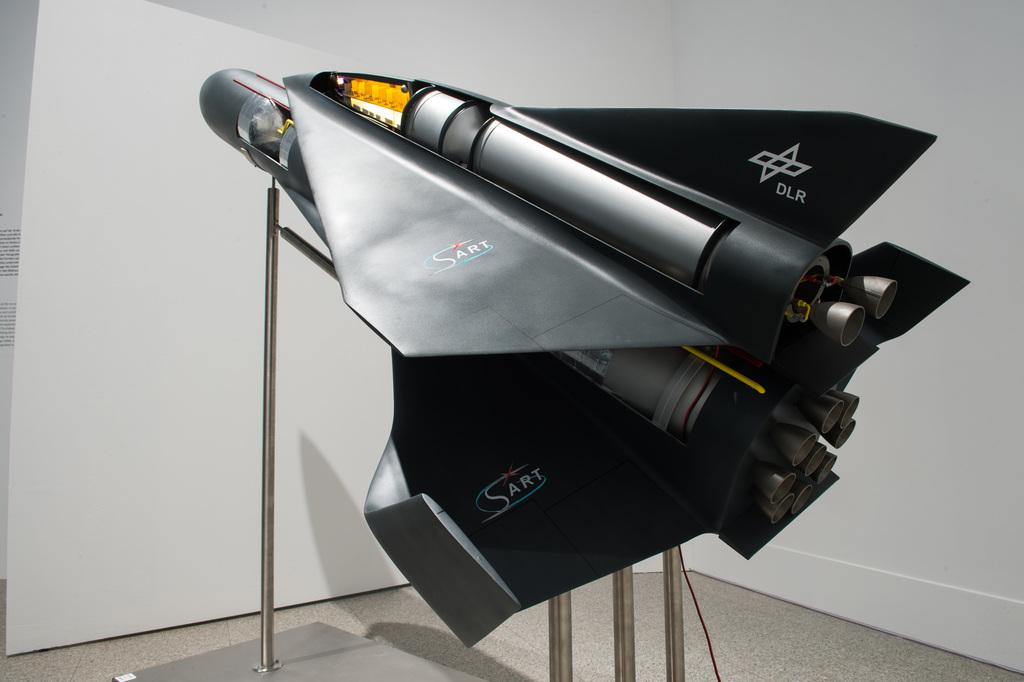<image>
Present a compact description of the photo's key features. a black SART engine on a silver pedestal 